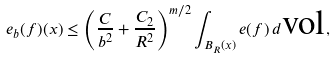<formula> <loc_0><loc_0><loc_500><loc_500>e _ { b } ( f ) ( x ) \leq \left ( \frac { C } { b ^ { 2 } } + \frac { C _ { 2 } } { R ^ { 2 } } \right ) ^ { m / 2 } \int _ { B _ { R } ( x ) } e ( f ) \, d \text {vol} ,</formula> 